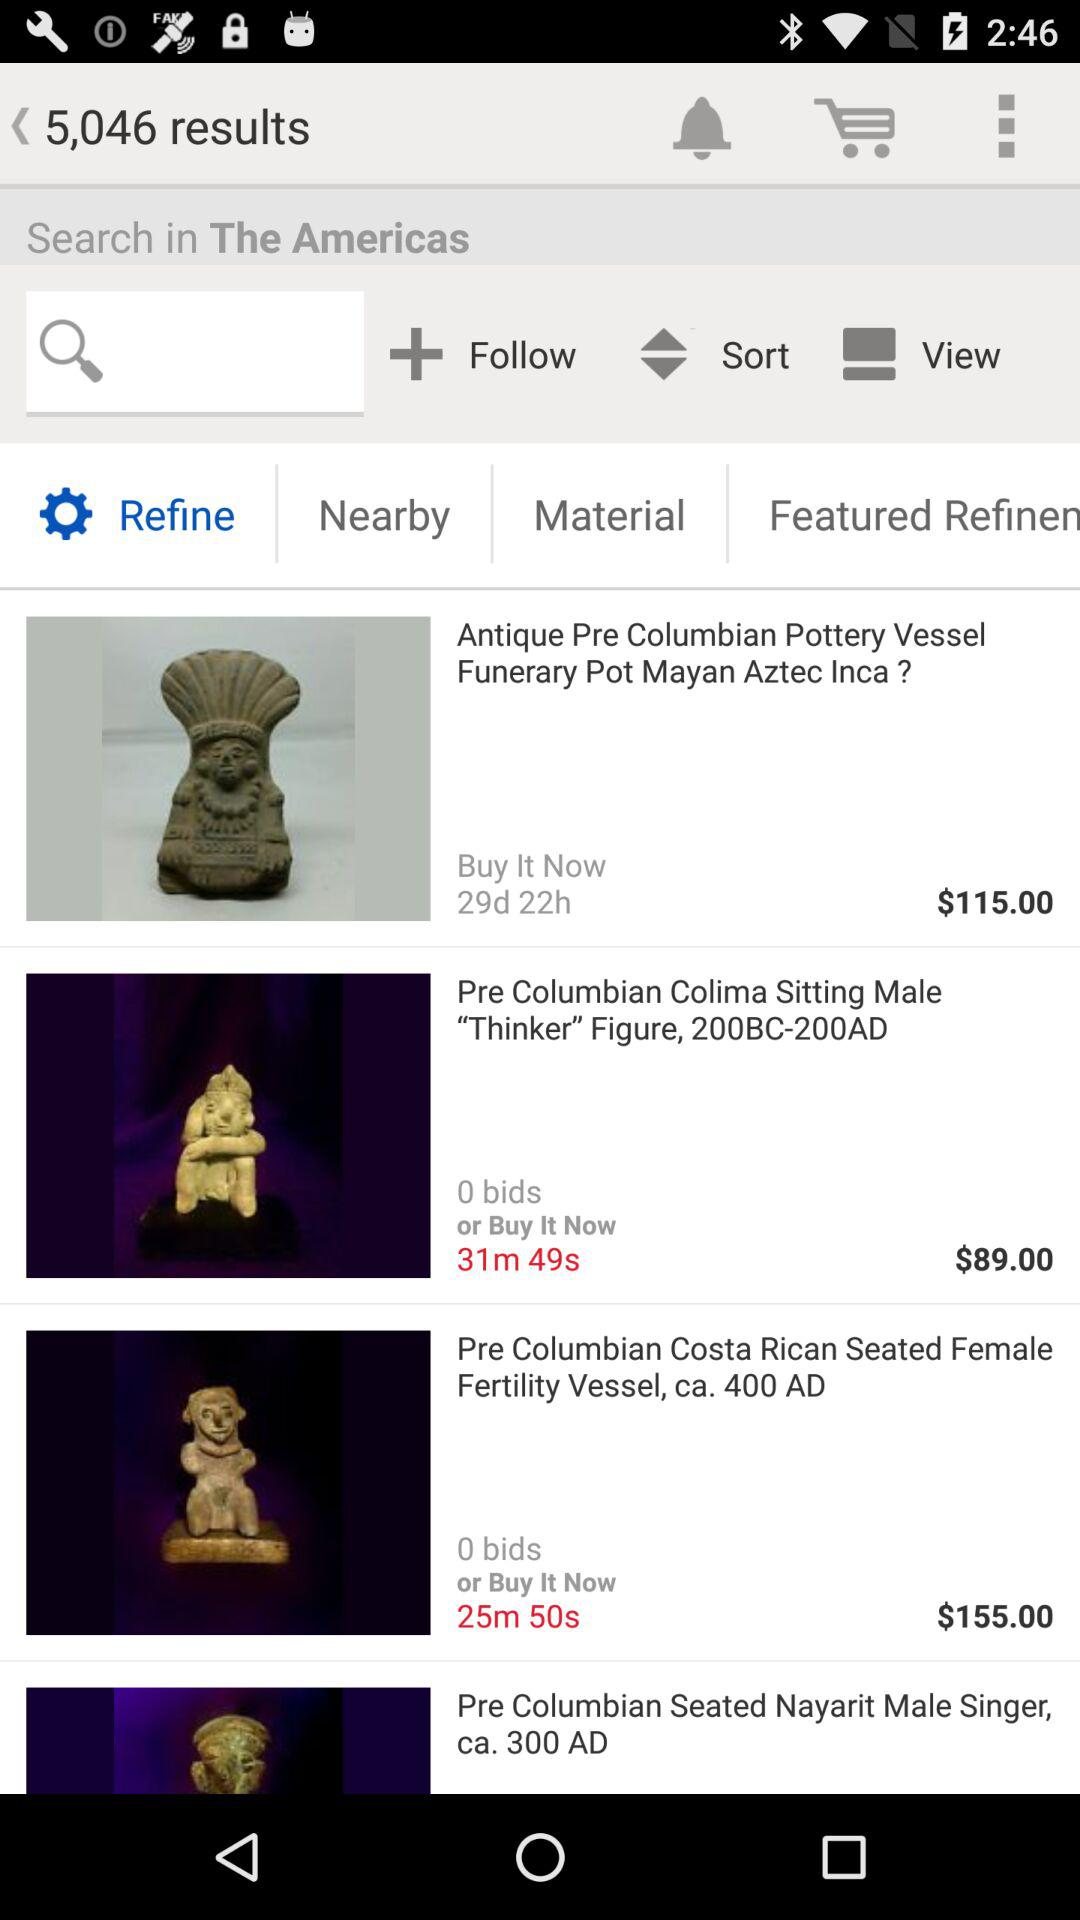In how many minutes will the "Pre Columbian Colima Sitting Male" auction end? The auction will end in 31 minutes and 49 seconds. 